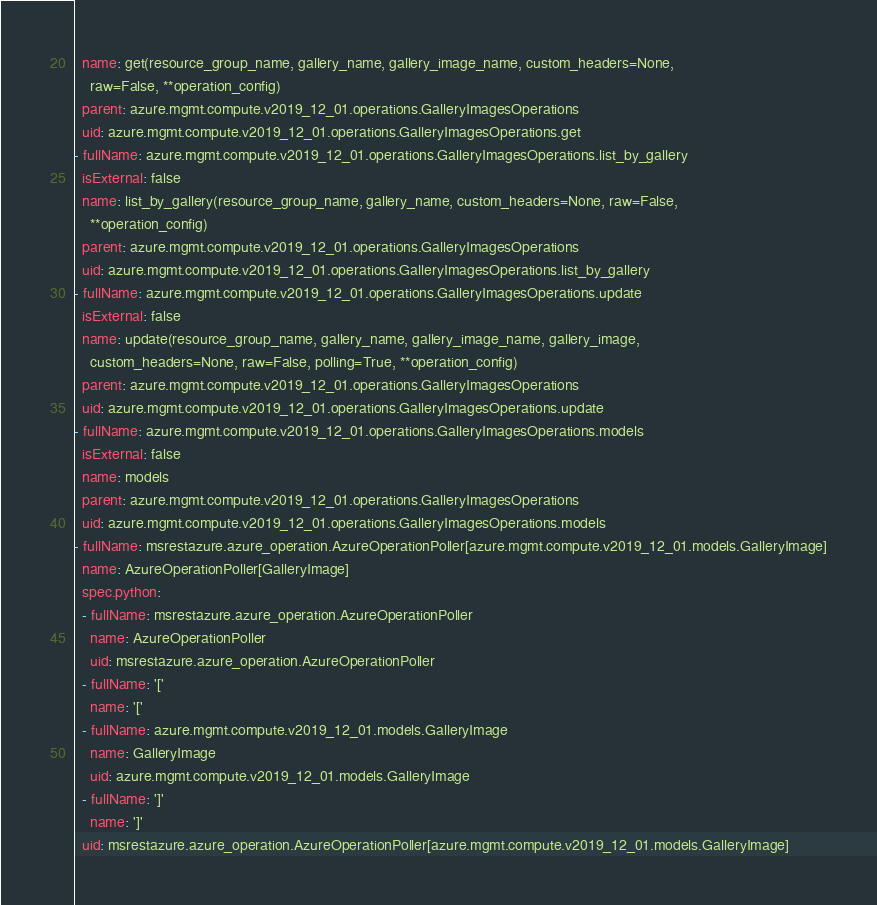Convert code to text. <code><loc_0><loc_0><loc_500><loc_500><_YAML_>  name: get(resource_group_name, gallery_name, gallery_image_name, custom_headers=None,
    raw=False, **operation_config)
  parent: azure.mgmt.compute.v2019_12_01.operations.GalleryImagesOperations
  uid: azure.mgmt.compute.v2019_12_01.operations.GalleryImagesOperations.get
- fullName: azure.mgmt.compute.v2019_12_01.operations.GalleryImagesOperations.list_by_gallery
  isExternal: false
  name: list_by_gallery(resource_group_name, gallery_name, custom_headers=None, raw=False,
    **operation_config)
  parent: azure.mgmt.compute.v2019_12_01.operations.GalleryImagesOperations
  uid: azure.mgmt.compute.v2019_12_01.operations.GalleryImagesOperations.list_by_gallery
- fullName: azure.mgmt.compute.v2019_12_01.operations.GalleryImagesOperations.update
  isExternal: false
  name: update(resource_group_name, gallery_name, gallery_image_name, gallery_image,
    custom_headers=None, raw=False, polling=True, **operation_config)
  parent: azure.mgmt.compute.v2019_12_01.operations.GalleryImagesOperations
  uid: azure.mgmt.compute.v2019_12_01.operations.GalleryImagesOperations.update
- fullName: azure.mgmt.compute.v2019_12_01.operations.GalleryImagesOperations.models
  isExternal: false
  name: models
  parent: azure.mgmt.compute.v2019_12_01.operations.GalleryImagesOperations
  uid: azure.mgmt.compute.v2019_12_01.operations.GalleryImagesOperations.models
- fullName: msrestazure.azure_operation.AzureOperationPoller[azure.mgmt.compute.v2019_12_01.models.GalleryImage]
  name: AzureOperationPoller[GalleryImage]
  spec.python:
  - fullName: msrestazure.azure_operation.AzureOperationPoller
    name: AzureOperationPoller
    uid: msrestazure.azure_operation.AzureOperationPoller
  - fullName: '['
    name: '['
  - fullName: azure.mgmt.compute.v2019_12_01.models.GalleryImage
    name: GalleryImage
    uid: azure.mgmt.compute.v2019_12_01.models.GalleryImage
  - fullName: ']'
    name: ']'
  uid: msrestazure.azure_operation.AzureOperationPoller[azure.mgmt.compute.v2019_12_01.models.GalleryImage]</code> 